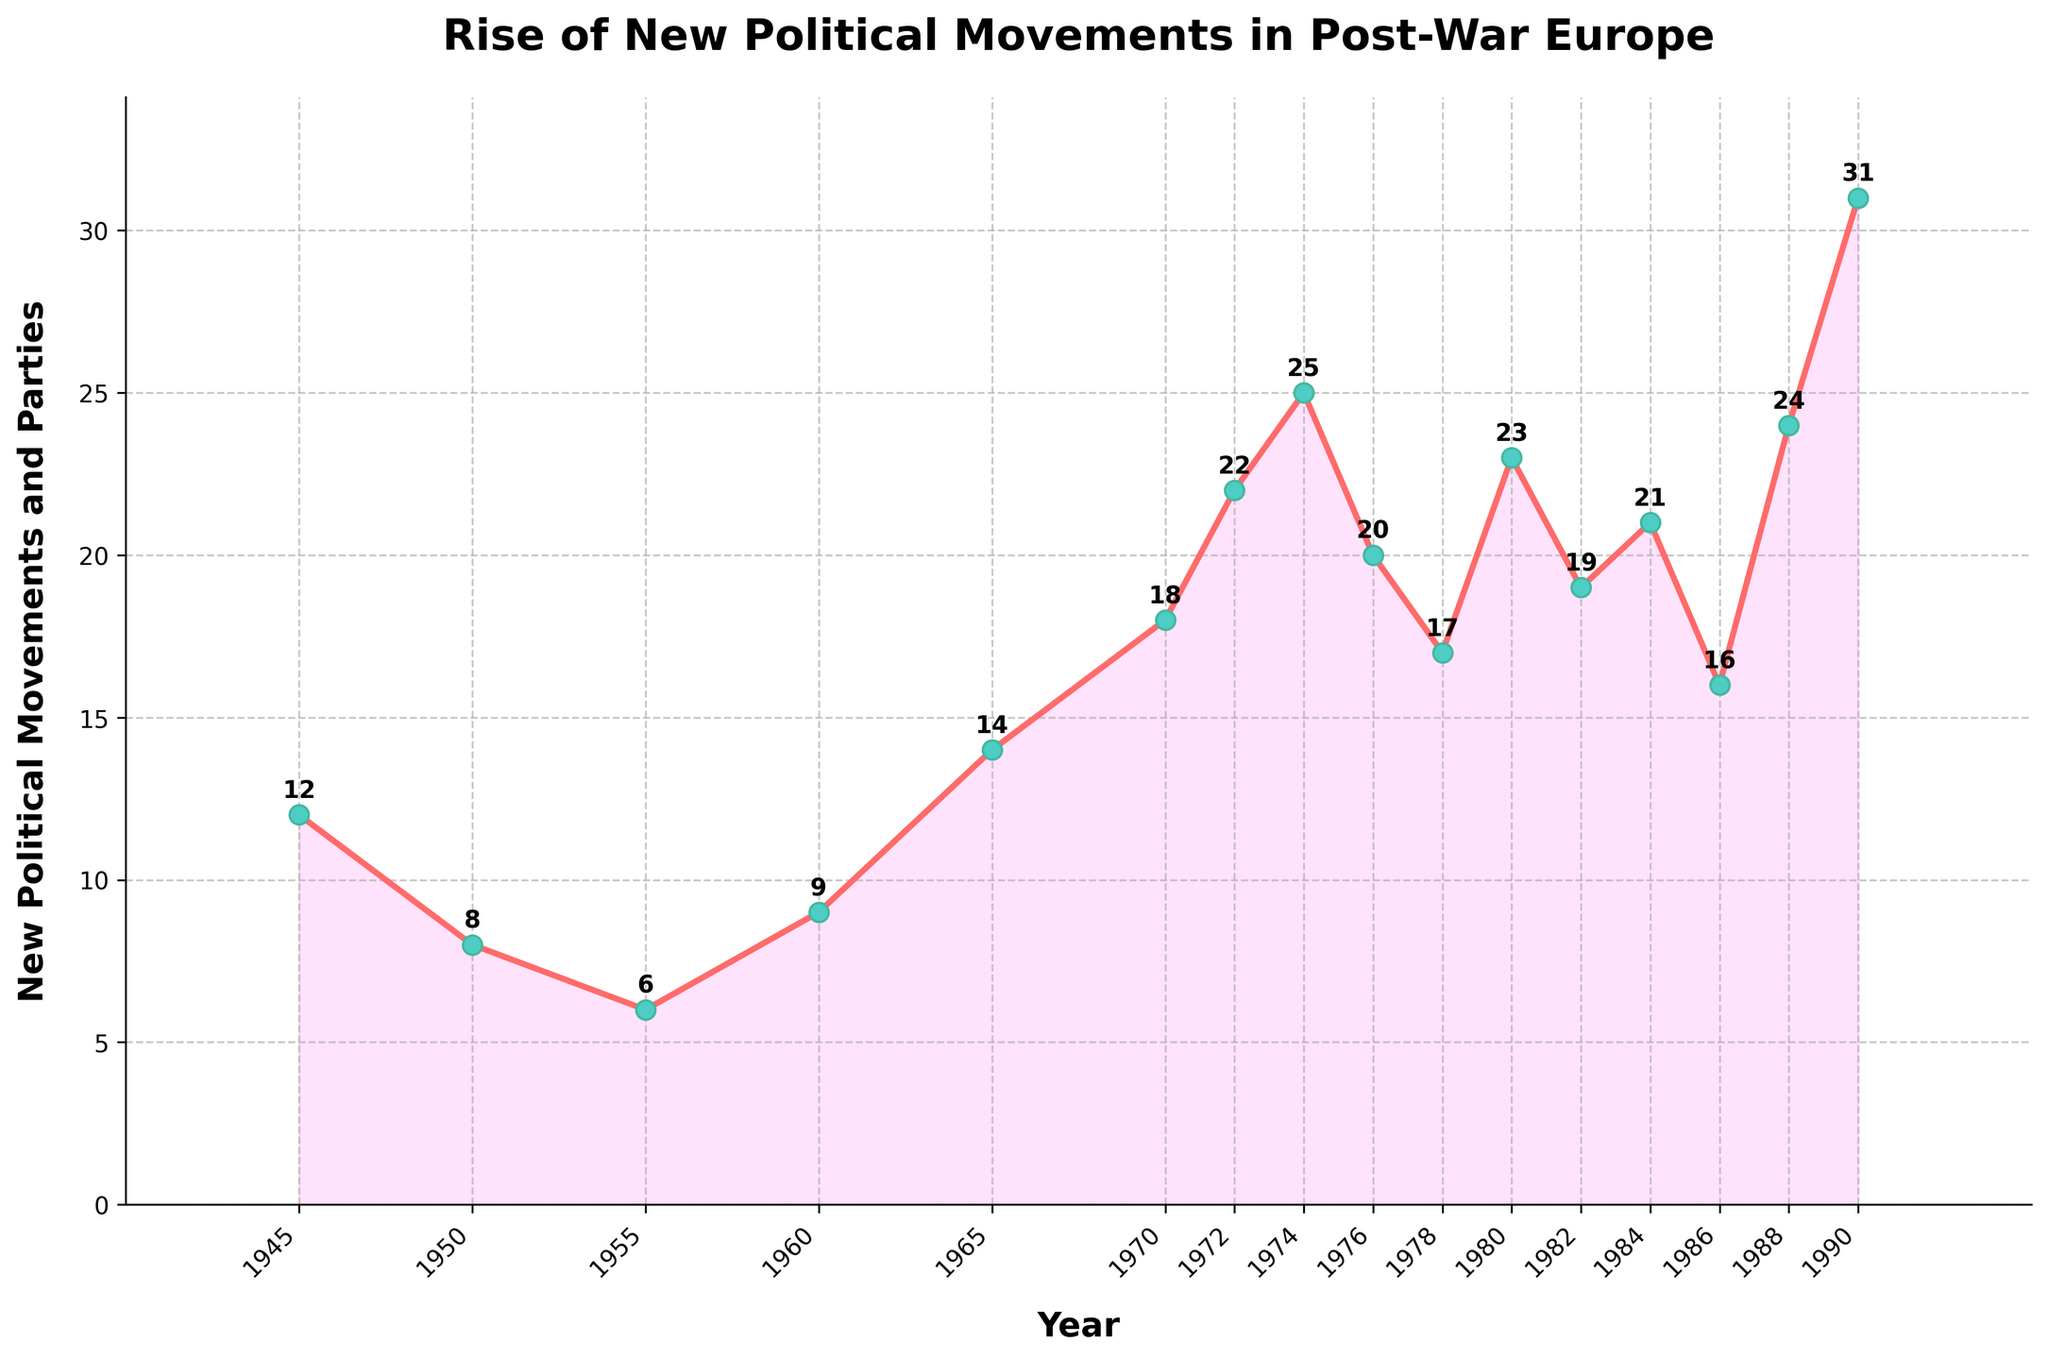How many new political movements and parties were there in 1950 and 1980 combined? To find the total, add the number of new political movements and parties in 1950 (8) and 1980 (23): 8 + 23 = 31
Answer: 31 Which year had the highest number of new political movements and parties? Look for the peak point on the line chart. The year with the highest point is 1990 with 31 new political movements and parties
Answer: 1990 What is the general trend of new political movements and parties formed from 1970 to 1980? Observe the plotted points between 1970 to 1980. The values are 18 (1970), 22 (1972), 25 (1974), 20 (1976), 17 (1978), and 23 (1980). There is a rise from 1970 to 1974, followed by ups and downs. The general trend seems to be an initial increase and then some fluctuation
Answer: Initial increase followed by fluctuation How many years had more than 20 new political movements and parties? Count the years where the plotted values are greater than 20. The years are: 1972 (22), 1974 (25), 1980 (23), 1984 (21), 1988 (24), and 1990 (31). There are 6 such years
Answer: 6 What is the average number of new political movements and parties formed annually from 1945 to 1955? Calculate the average by summing the values and dividing by the number of years. (12 + 8 + 6) / 3 = 26 / 3 = approximately 8.67
Answer: Approximately 8.67 Between which consecutive years was the largest increase in new political movements and parties observed? Find the difference in values between consecutive years and identify the largest one. The largest increase is between 1988 (24) and 1990 (31) with an increase of 31 - 24 = 7
Answer: 1988 to 1990 In which year does the number of new political movements and parties equal 14? Locate the year corresponding to the plotted value of 14. This occurs in 1965
Answer: 1965 How many more new political movements and parties were there in 1990 compared to 1982? Subtract the number for 1982 (19) from that for 1990 (31): 31 - 19 = 12
Answer: 12 Is the number of new political movements and parties higher in 1978 or 1984? Compare the values for the years 1978 (17) and 1984 (21). 21 is higher than 17
Answer: 1984 What color is used for the line connecting the data points? The line color is a shade of red, as observed in the chart
Answer: Red 